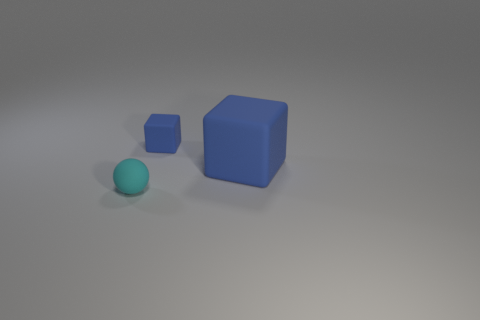Add 3 blue blocks. How many objects exist? 6 Subtract 1 blocks. How many blocks are left? 1 Subtract all tiny spheres. Subtract all big blue matte cubes. How many objects are left? 1 Add 2 small balls. How many small balls are left? 3 Add 2 matte objects. How many matte objects exist? 5 Subtract 0 purple blocks. How many objects are left? 3 Subtract all blocks. How many objects are left? 1 Subtract all yellow balls. Subtract all purple blocks. How many balls are left? 1 Subtract all cyan balls. How many cyan blocks are left? 0 